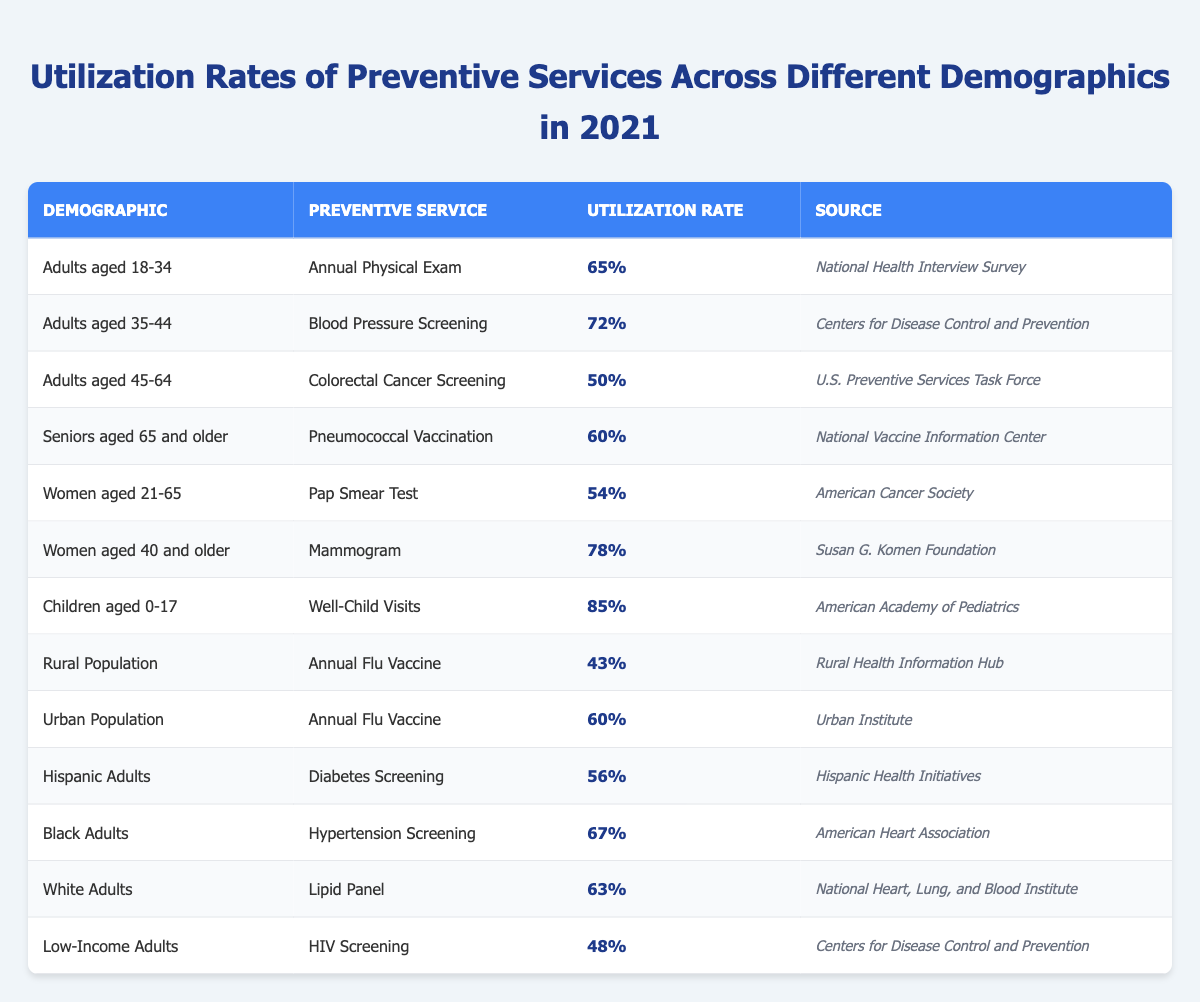What is the utilization rate for Well-Child Visits among children aged 0-17? According to the table, the utilization rate for Well-Child Visits among children aged 0-17 is 85%.
Answer: 85% Which preventive service has the highest utilization rate? The highest utilization rate is for Well-Child Visits, which is 85%.
Answer: 85% What is the utilization rate for the Annual Flu Vaccine in the Rural Population? The table shows that the utilization rate for the Annual Flu Vaccine in the Rural Population is 43%.
Answer: 43% Is the utilization rate for Pap Smear Tests among Women aged 21-65 greater than or equal to 60%? The rate for Pap Smear Tests among this demographic is 54%, which is less than 60%, so the answer is no.
Answer: No What is the difference in utilization rates between Blood Pressure Screening for adults aged 35-44 and Lipid Panel for White Adults? Blood Pressure Screening is at 72% and Lipid Panel is at 63%. The difference is 72% - 63% = 9%.
Answer: 9% What is the average utilization rate for preventive services across all demographics listed in the table? Adding the rates (65 + 72 + 50 + 60 + 54 + 78 + 85 + 43 + 60 + 56 + 67 + 63 + 48) gives  37, and there are 13 demographic categories, so the average is  37 / 13 = 56.54%.
Answer: Approximately 56.54% How does the utilization rate of the Annual Flu Vaccine in Urban populations compare to that in Rural populations? The rate for Urban populations is 60%, while for Rural populations it is 43%. Therefore, Urban populations have a higher rate by 17%.
Answer: Higher by 17% Which demographic has the lowest utilization rate, and what is the rate? The demographic with the lowest utilization rate is the Rural Population with 43%.
Answer: Rural Population with 43% Are the utilization rates among women aged 40 and older higher than those among women aged 21-65? The rate for women aged 40 and older (Mammogram) is 78%, and for those aged 21-65 (Pap Smear Test) it is 54%, so yes, the rates are higher for older women.
Answer: Yes What is the total utilization rate for preventive services targeted at the elderly (aged 65 and older)? The only preventive service listed for seniors aged 65 and older is Pneumococcal Vaccination, which has a utilization rate of 60%.
Answer: 60% 